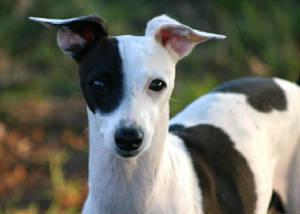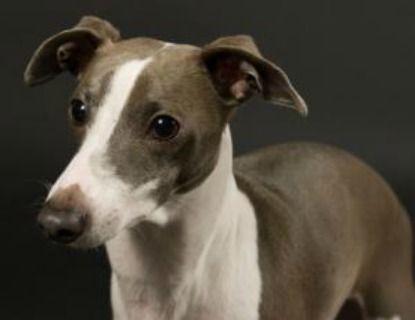The first image is the image on the left, the second image is the image on the right. Given the left and right images, does the statement "One dog has a collar on." hold true? Answer yes or no. No. 